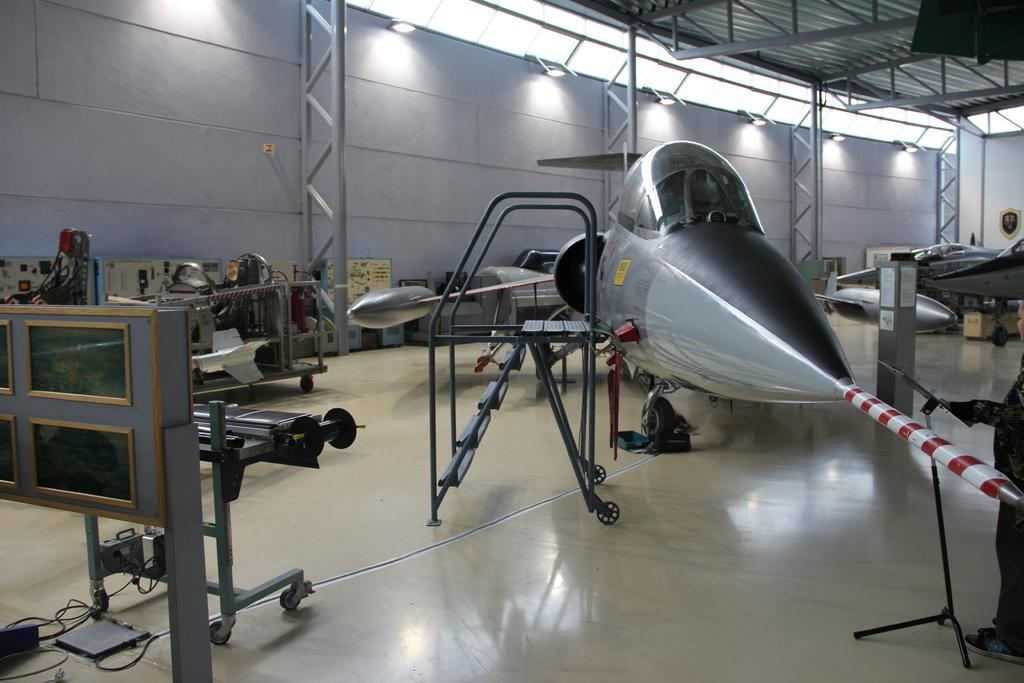What type of space is depicted in the image? The image shows an inner view of a room. What structural elements can be seen in the room? There are walls in the room. What type of lighting is present in the room? Electric lights are present in the room. Are there any security features in the room? Yes, iron grills are visible in the room. What other items can be found in the room? Spare parts and a ladder are in the room. What is the primary purpose of the room? The presence of aircrafts in the room suggests that it is related to aviation or aircraft maintenance. What type of coach can be seen in the image? There is no coach present in the image; it depicts an inner view of a room with aircrafts and related equipment. 